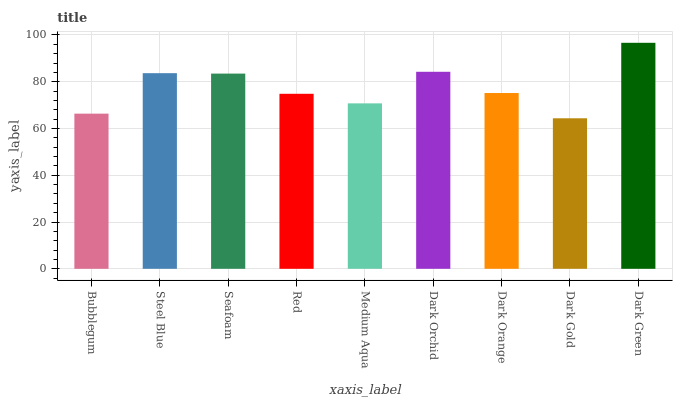Is Dark Gold the minimum?
Answer yes or no. Yes. Is Dark Green the maximum?
Answer yes or no. Yes. Is Steel Blue the minimum?
Answer yes or no. No. Is Steel Blue the maximum?
Answer yes or no. No. Is Steel Blue greater than Bubblegum?
Answer yes or no. Yes. Is Bubblegum less than Steel Blue?
Answer yes or no. Yes. Is Bubblegum greater than Steel Blue?
Answer yes or no. No. Is Steel Blue less than Bubblegum?
Answer yes or no. No. Is Dark Orange the high median?
Answer yes or no. Yes. Is Dark Orange the low median?
Answer yes or no. Yes. Is Dark Orchid the high median?
Answer yes or no. No. Is Bubblegum the low median?
Answer yes or no. No. 